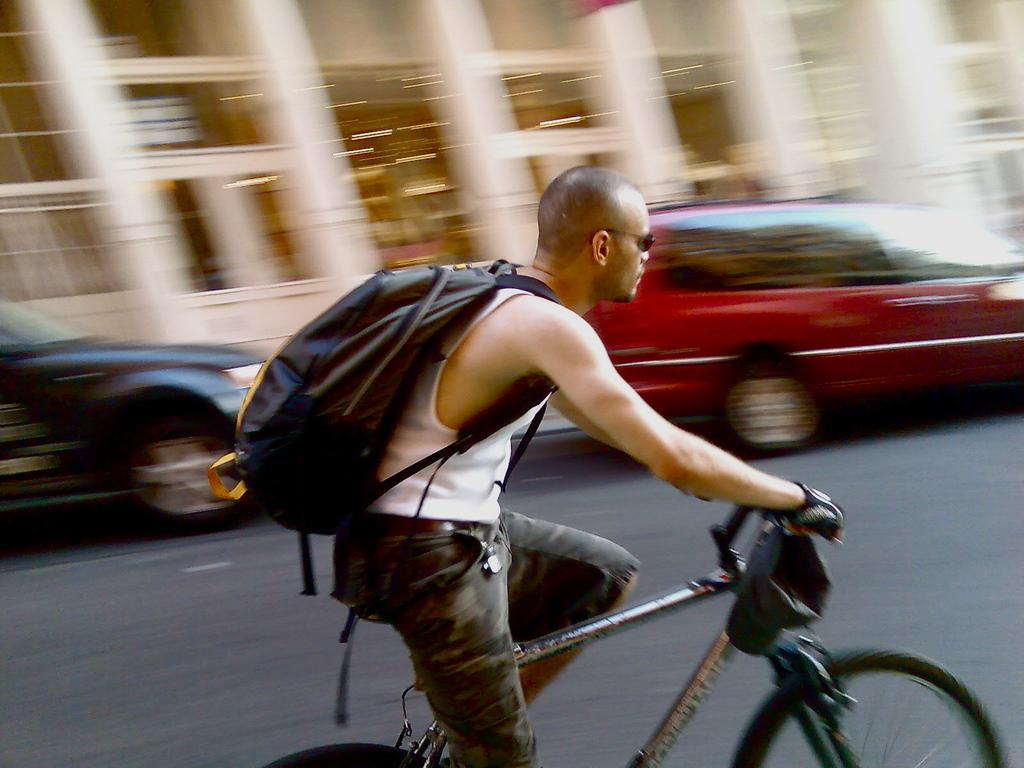What is the man in the image doing? The man is riding a bicycle in the image. What is the man carrying while riding the bicycle? The man is wearing a bag. What can be seen on the road in the image? There are vehicles on the road in the image. What type of structure is visible in the image? There is a building in the image. What color is the crowd in the image? There is no crowd present in the image. 